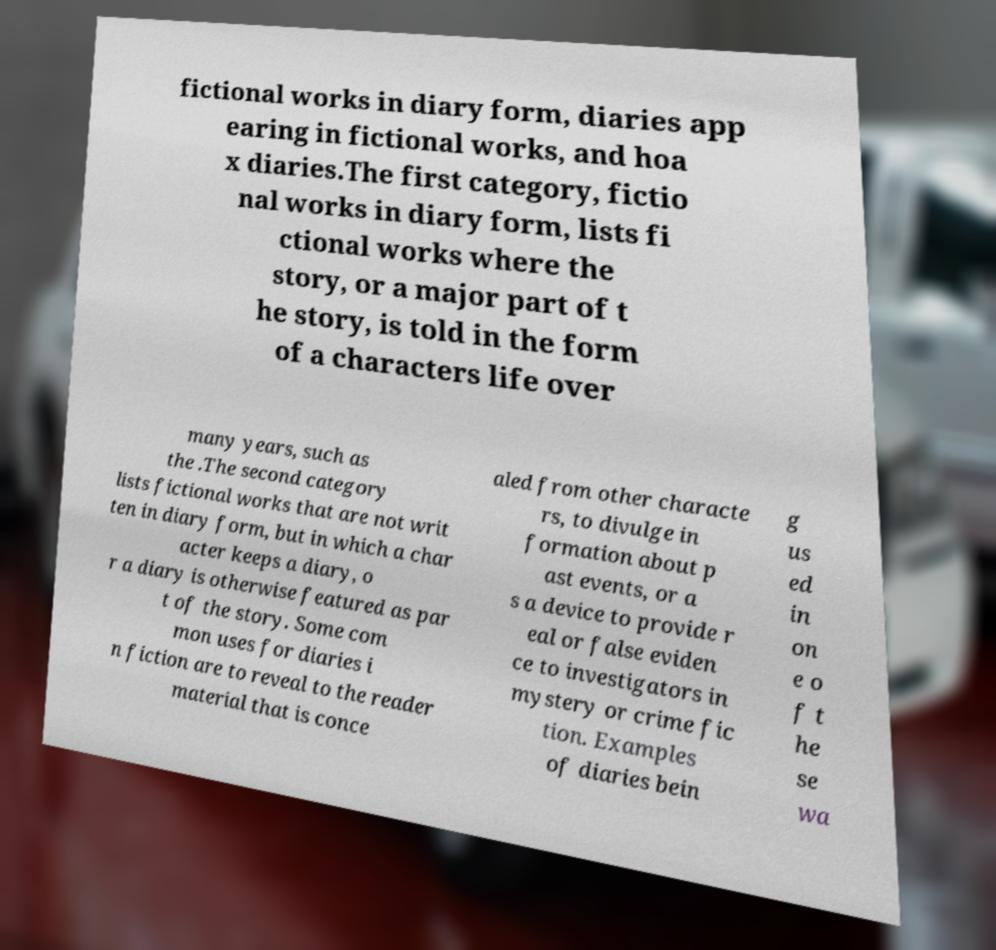For documentation purposes, I need the text within this image transcribed. Could you provide that? fictional works in diary form, diaries app earing in fictional works, and hoa x diaries.The first category, fictio nal works in diary form, lists fi ctional works where the story, or a major part of t he story, is told in the form of a characters life over many years, such as the .The second category lists fictional works that are not writ ten in diary form, but in which a char acter keeps a diary, o r a diary is otherwise featured as par t of the story. Some com mon uses for diaries i n fiction are to reveal to the reader material that is conce aled from other characte rs, to divulge in formation about p ast events, or a s a device to provide r eal or false eviden ce to investigators in mystery or crime fic tion. Examples of diaries bein g us ed in on e o f t he se wa 